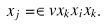<formula> <loc_0><loc_0><loc_500><loc_500>x _ { j } & = \in v x _ { k } x _ { i } x _ { k } .</formula> 